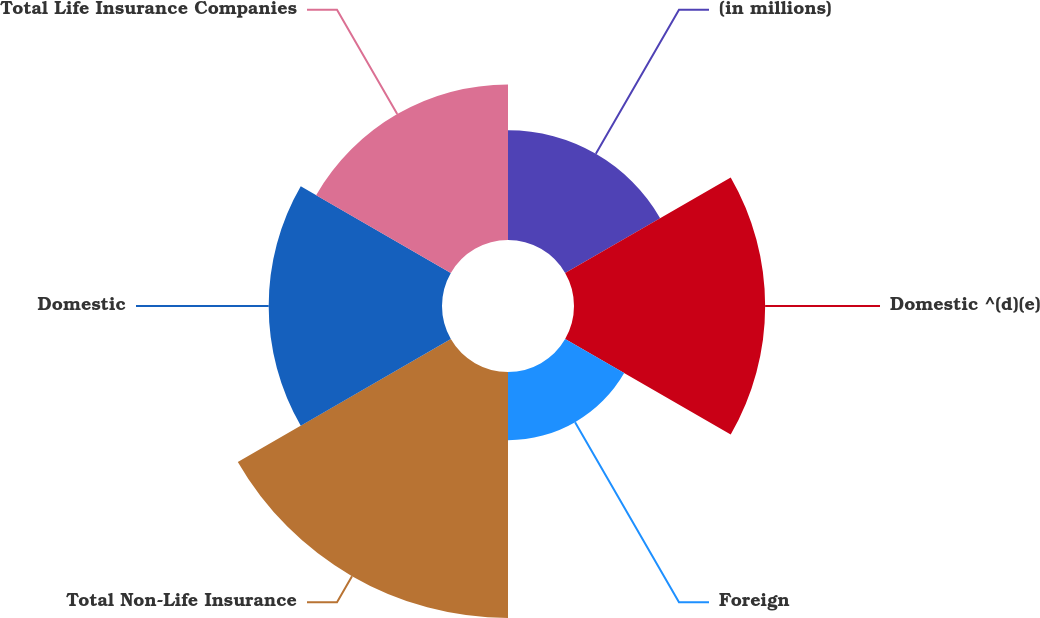Convert chart. <chart><loc_0><loc_0><loc_500><loc_500><pie_chart><fcel>(in millions)<fcel>Domestic ^(d)(e)<fcel>Foreign<fcel>Total Non-Life Insurance<fcel>Domestic<fcel>Total Life Insurance Companies<nl><fcel>11.62%<fcel>20.25%<fcel>7.22%<fcel>26.06%<fcel>18.36%<fcel>16.48%<nl></chart> 